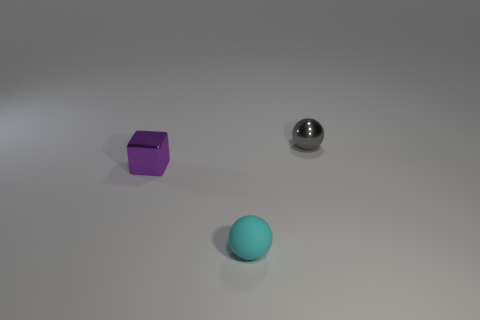Add 3 metallic cubes. How many objects exist? 6 Subtract all balls. How many objects are left? 1 Add 1 small rubber things. How many small rubber things exist? 2 Subtract 0 gray cylinders. How many objects are left? 3 Subtract all cyan spheres. Subtract all tiny matte spheres. How many objects are left? 1 Add 1 small metal balls. How many small metal balls are left? 2 